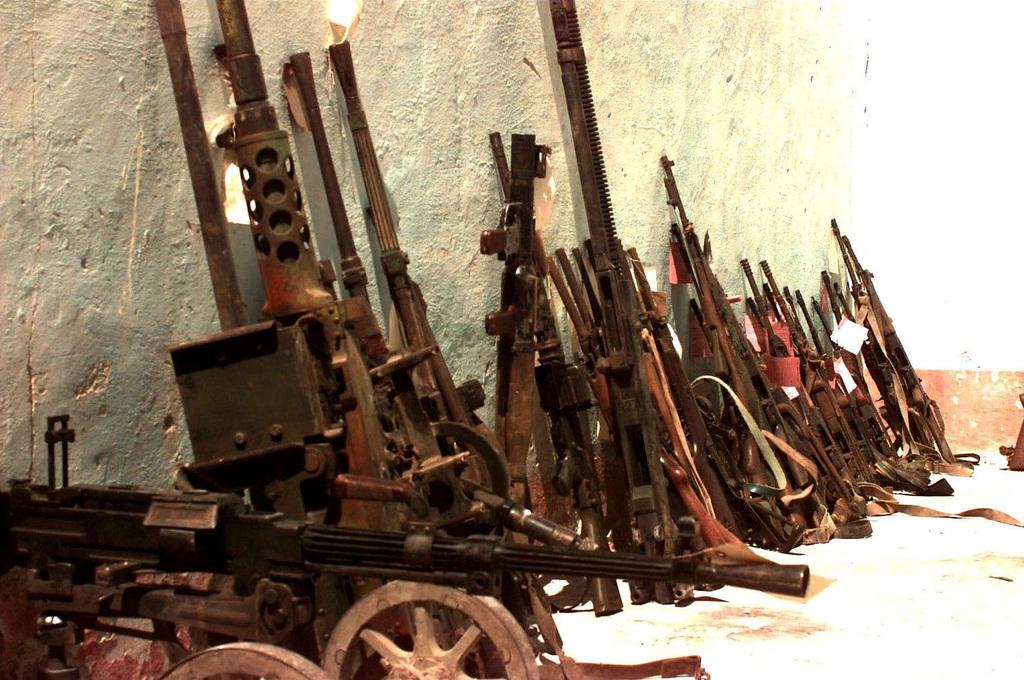What type of objects are on the floor in the image? There are metal objects on the floor in the image. What can be seen in the background of the image? There is a wall visible in the background of the image. What type of twig is being exchanged between the metal objects in the image? There is no twig present in the image, nor is there any exchange happening between the metal objects. 